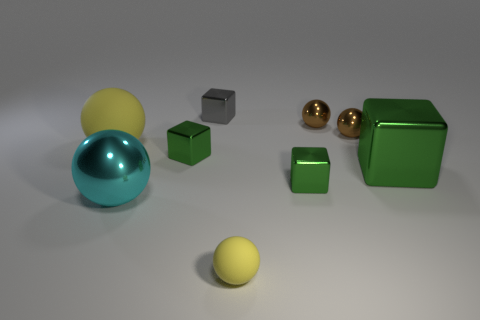Subtract all gray cylinders. How many green cubes are left? 3 Subtract all cyan balls. How many balls are left? 4 Subtract all big yellow spheres. How many spheres are left? 4 Subtract all gray balls. Subtract all green cubes. How many balls are left? 5 Add 1 yellow spheres. How many objects exist? 10 Subtract all cubes. How many objects are left? 5 Add 2 big yellow matte objects. How many big yellow matte objects exist? 3 Subtract 0 cyan cubes. How many objects are left? 9 Subtract all tiny blocks. Subtract all large matte objects. How many objects are left? 5 Add 6 large yellow objects. How many large yellow objects are left? 7 